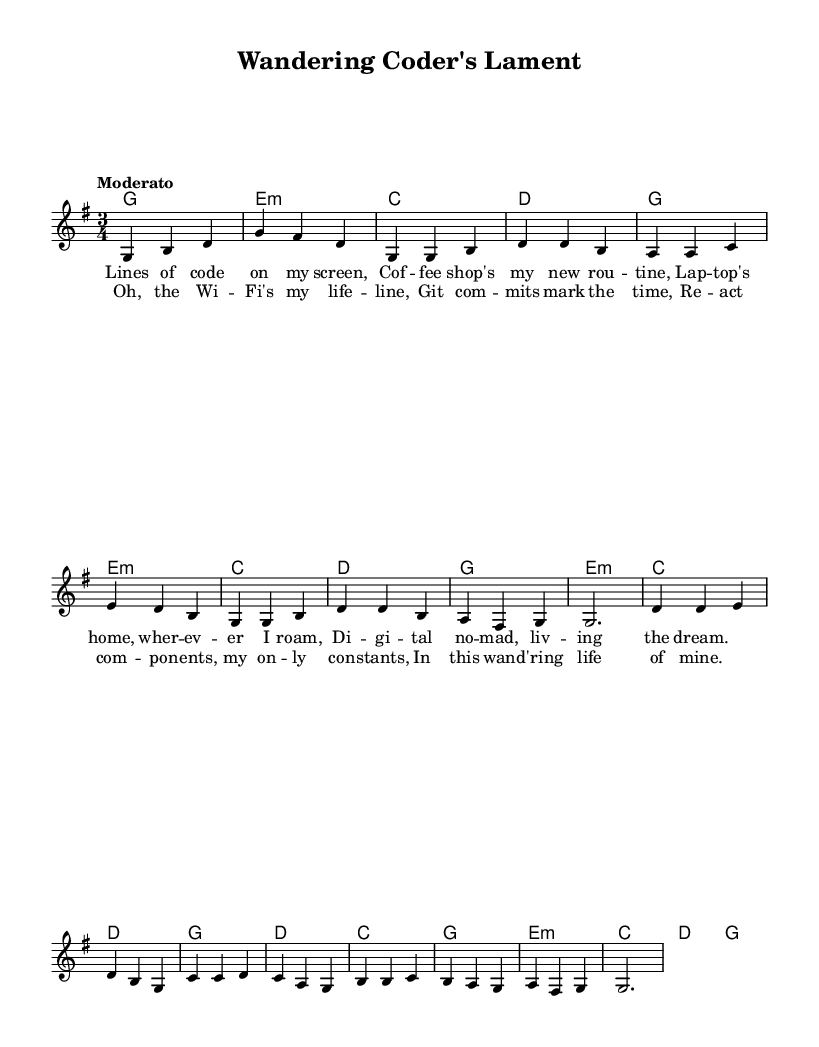What is the key signature of this music? The key signature is G major, which has one sharp (F#). This can be identified at the beginning of the score where the key signature is indicated.
Answer: G major What is the time signature of this music? The time signature is 3/4, which indicates that there are three beats in each measure and the quarter note gets one beat. This is shown at the beginning of the score right next to the key signature.
Answer: 3/4 What is the tempo marking for this piece? The tempo marking is "Moderato", which suggests a moderate speed of performance. This is found at the beginning of the score under the time signature and key indication.
Answer: Moderato How many measures are in the verse? There are eight measures in the verse. By counting each measure in the verse section where the lyrics are placed, we can identify that there are exactly eight measures before the chorus follows.
Answer: Eight What instruments are used in this arrangement? The arrangement includes a single staff for melodies and chords, indicating that it is likely intended for a vocalist accompanied by a chordal instrument or guitar, based on typical folk music instrumentation. This can be inferred from the absence of additional staves or instrument designation in the score.
Answer: Single staff What is the primary theme explored in the lyrics? The primary theme explored in the lyrics is digital nomadism, which is evident from phrases like "digital nomad" and references to code and coffee shops. By analyzing the content of the lyrics, it becomes clear that the story revolves around the lifestyle of working remotely while traveling.
Answer: Digital nomadism 